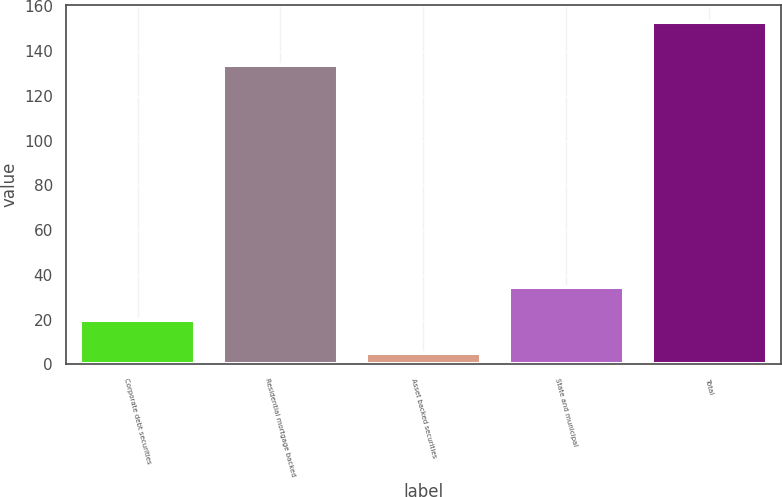<chart> <loc_0><loc_0><loc_500><loc_500><bar_chart><fcel>Corporate debt securities<fcel>Residential mortgage backed<fcel>Asset backed securities<fcel>State and municipal<fcel>Total<nl><fcel>19.8<fcel>134<fcel>5<fcel>34.6<fcel>153<nl></chart> 